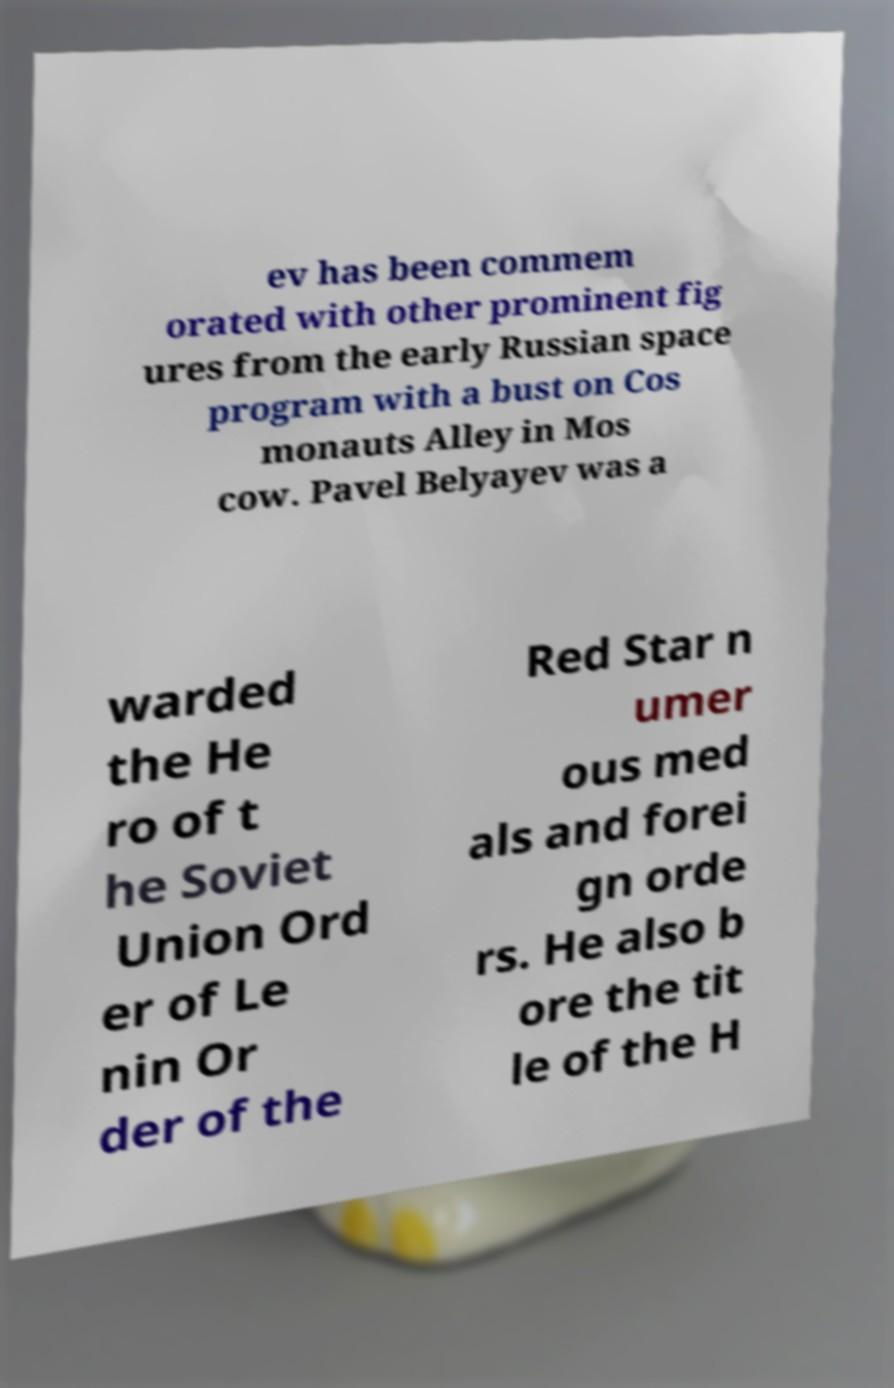There's text embedded in this image that I need extracted. Can you transcribe it verbatim? ev has been commem orated with other prominent fig ures from the early Russian space program with a bust on Cos monauts Alley in Mos cow. Pavel Belyayev was a warded the He ro of t he Soviet Union Ord er of Le nin Or der of the Red Star n umer ous med als and forei gn orde rs. He also b ore the tit le of the H 